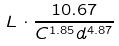Convert formula to latex. <formula><loc_0><loc_0><loc_500><loc_500>L \cdot \frac { 1 0 . 6 7 } { C ^ { 1 . 8 5 } d ^ { 4 . 8 7 } }</formula> 